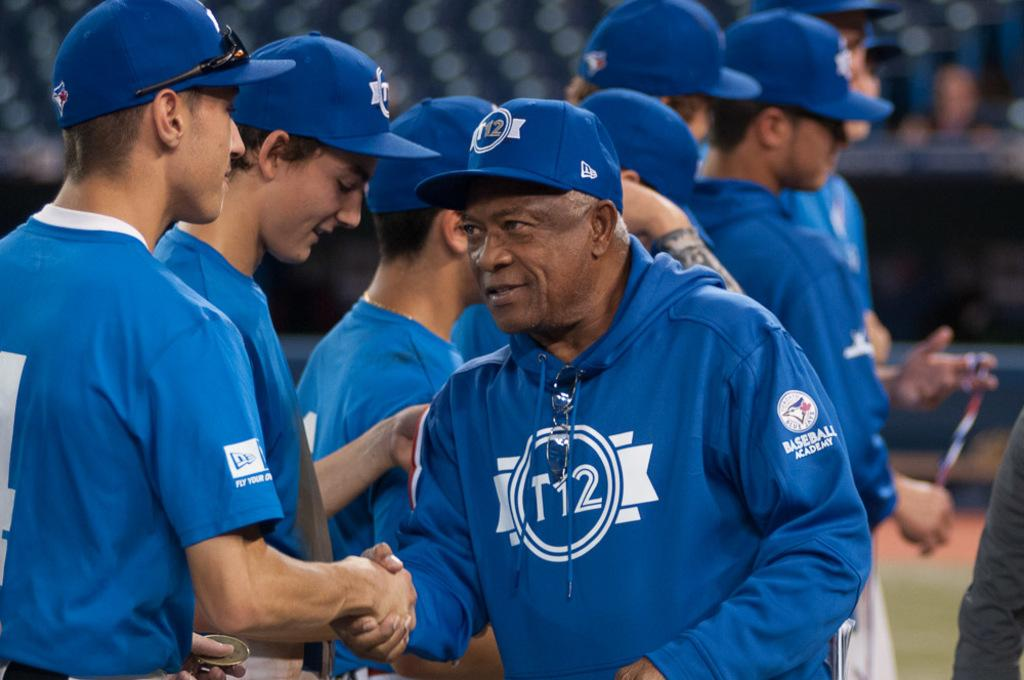<image>
Share a concise interpretation of the image provided. a man with the number 12 on their baseball hat 